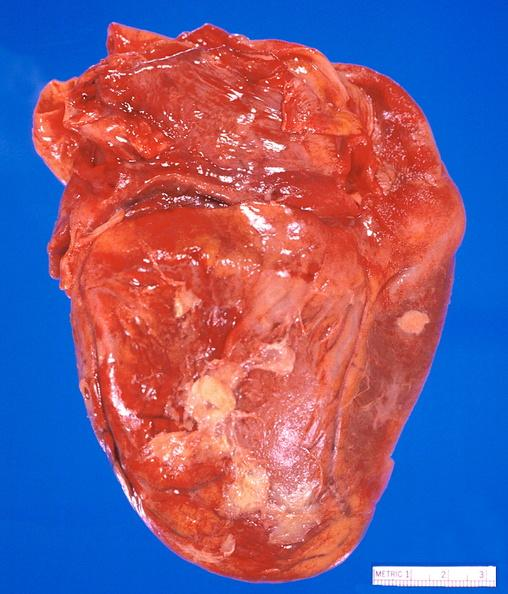where is this?
Answer the question using a single word or phrase. Heart 